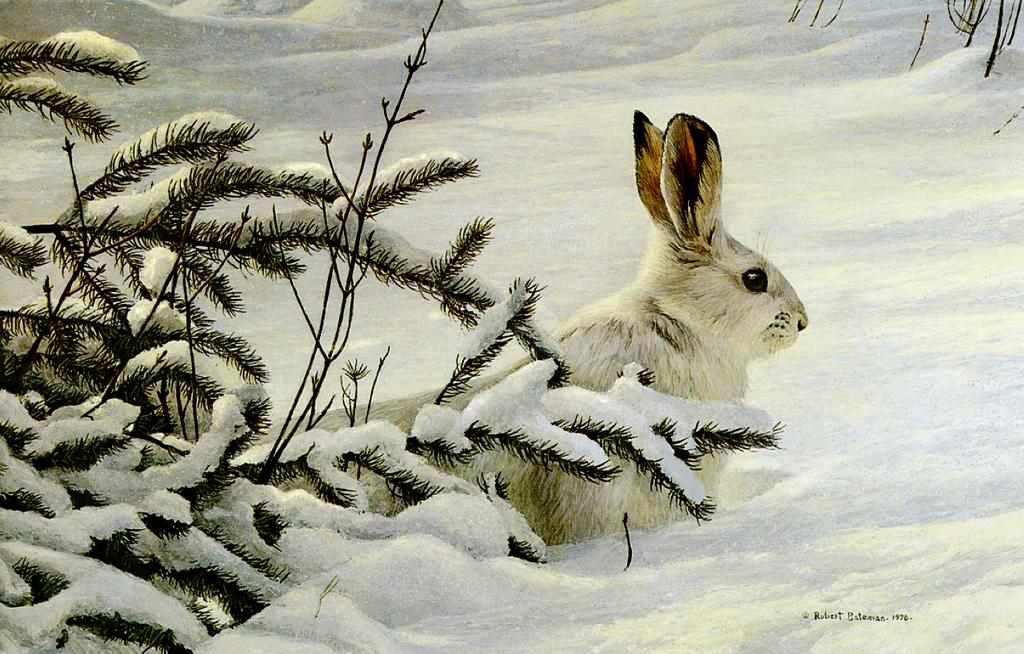What is the main subject in the center of the image? There is a rabbit in the center of the image. What type of vegetation can be seen on the left side of the image? Small bushes are present on the left side of the image. What is the background of the image characterized by? Snow is visible in the background of the image. How many dimes are scattered around the rabbit in the image? There are no dimes present in the image; it features a rabbit, small bushes, and snow. What type of steel structure can be seen in the image? There is no steel structure present in the image. 